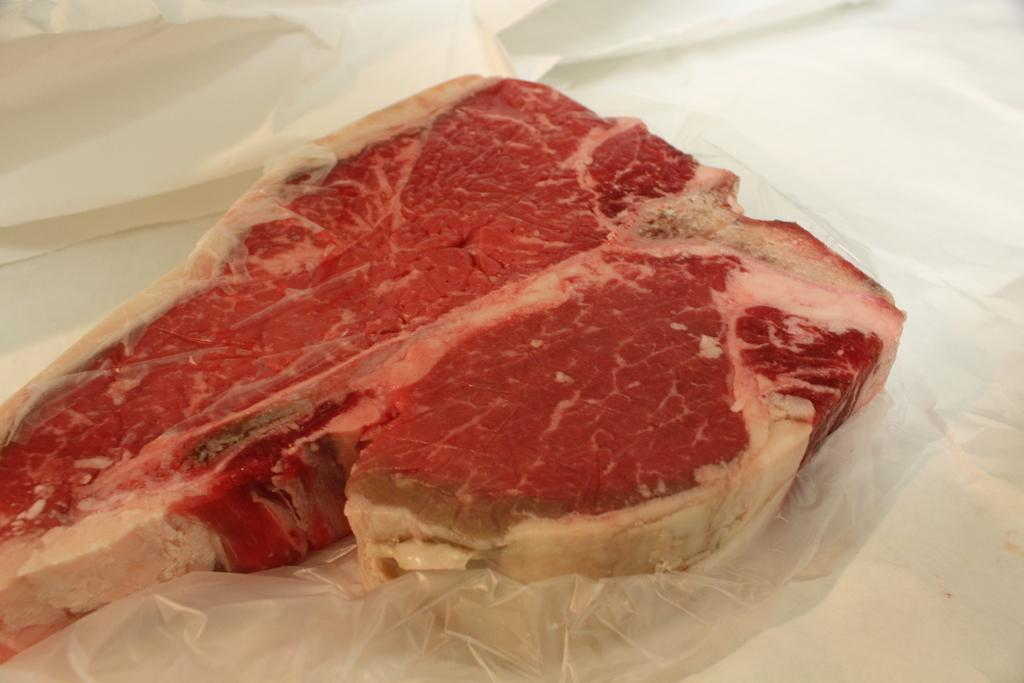What type of food is visible in the image? There is red color meat in the image. How is the meat being stored or protected in the image? The meat is covered with a plastic cover. What is the meat placed on in the image? The meat is placed on a white color sheet. What can be seen in the background of the image? There is a white color cloth in the background of the image. How many tomatoes are on the sidewalk in the image? There are no tomatoes or sidewalks present in the image. What type of class is being taught in the image? There is no class or teaching activity depicted in the image. 